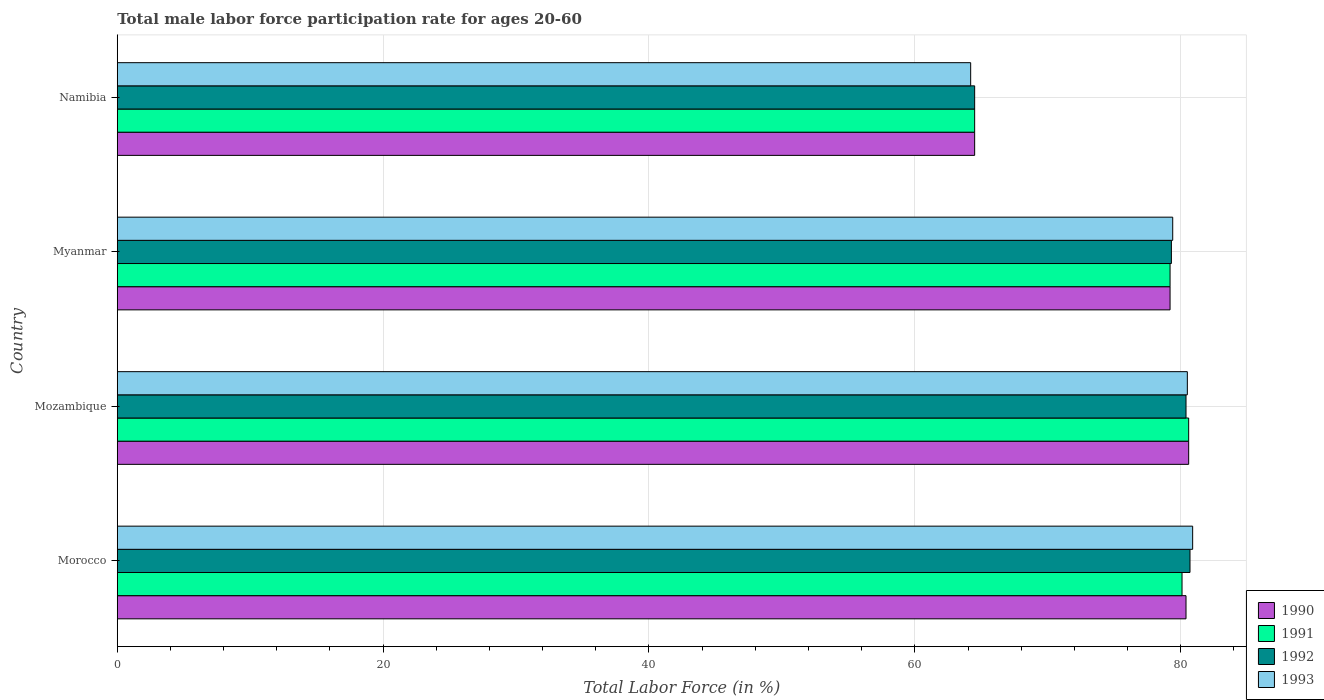Are the number of bars on each tick of the Y-axis equal?
Your answer should be very brief. Yes. How many bars are there on the 4th tick from the bottom?
Provide a short and direct response. 4. What is the label of the 4th group of bars from the top?
Offer a terse response. Morocco. What is the male labor force participation rate in 1992 in Mozambique?
Provide a short and direct response. 80.4. Across all countries, what is the maximum male labor force participation rate in 1990?
Give a very brief answer. 80.6. Across all countries, what is the minimum male labor force participation rate in 1993?
Your response must be concise. 64.2. In which country was the male labor force participation rate in 1993 maximum?
Offer a very short reply. Morocco. In which country was the male labor force participation rate in 1991 minimum?
Keep it short and to the point. Namibia. What is the total male labor force participation rate in 1990 in the graph?
Your answer should be very brief. 304.7. What is the difference between the male labor force participation rate in 1990 in Morocco and that in Mozambique?
Provide a succinct answer. -0.2. What is the difference between the male labor force participation rate in 1992 in Mozambique and the male labor force participation rate in 1991 in Myanmar?
Make the answer very short. 1.2. What is the average male labor force participation rate in 1990 per country?
Your answer should be compact. 76.17. What is the difference between the male labor force participation rate in 1990 and male labor force participation rate in 1991 in Morocco?
Provide a short and direct response. 0.3. What is the ratio of the male labor force participation rate in 1993 in Mozambique to that in Namibia?
Provide a succinct answer. 1.25. Is the male labor force participation rate in 1990 in Morocco less than that in Myanmar?
Ensure brevity in your answer.  No. What is the difference between the highest and the second highest male labor force participation rate in 1992?
Provide a succinct answer. 0.3. What is the difference between the highest and the lowest male labor force participation rate in 1992?
Provide a short and direct response. 16.2. Is it the case that in every country, the sum of the male labor force participation rate in 1990 and male labor force participation rate in 1992 is greater than the sum of male labor force participation rate in 1993 and male labor force participation rate in 1991?
Offer a terse response. No. What does the 3rd bar from the bottom in Mozambique represents?
Give a very brief answer. 1992. Is it the case that in every country, the sum of the male labor force participation rate in 1992 and male labor force participation rate in 1993 is greater than the male labor force participation rate in 1991?
Your answer should be compact. Yes. What is the difference between two consecutive major ticks on the X-axis?
Provide a short and direct response. 20. Does the graph contain grids?
Keep it short and to the point. Yes. Where does the legend appear in the graph?
Ensure brevity in your answer.  Bottom right. How many legend labels are there?
Offer a terse response. 4. What is the title of the graph?
Give a very brief answer. Total male labor force participation rate for ages 20-60. Does "1962" appear as one of the legend labels in the graph?
Give a very brief answer. No. What is the label or title of the Y-axis?
Your response must be concise. Country. What is the Total Labor Force (in %) of 1990 in Morocco?
Your answer should be compact. 80.4. What is the Total Labor Force (in %) of 1991 in Morocco?
Provide a succinct answer. 80.1. What is the Total Labor Force (in %) in 1992 in Morocco?
Offer a terse response. 80.7. What is the Total Labor Force (in %) in 1993 in Morocco?
Ensure brevity in your answer.  80.9. What is the Total Labor Force (in %) in 1990 in Mozambique?
Provide a short and direct response. 80.6. What is the Total Labor Force (in %) in 1991 in Mozambique?
Your answer should be very brief. 80.6. What is the Total Labor Force (in %) of 1992 in Mozambique?
Give a very brief answer. 80.4. What is the Total Labor Force (in %) in 1993 in Mozambique?
Ensure brevity in your answer.  80.5. What is the Total Labor Force (in %) in 1990 in Myanmar?
Offer a very short reply. 79.2. What is the Total Labor Force (in %) in 1991 in Myanmar?
Your response must be concise. 79.2. What is the Total Labor Force (in %) in 1992 in Myanmar?
Give a very brief answer. 79.3. What is the Total Labor Force (in %) in 1993 in Myanmar?
Give a very brief answer. 79.4. What is the Total Labor Force (in %) of 1990 in Namibia?
Offer a terse response. 64.5. What is the Total Labor Force (in %) in 1991 in Namibia?
Your response must be concise. 64.5. What is the Total Labor Force (in %) in 1992 in Namibia?
Your answer should be very brief. 64.5. What is the Total Labor Force (in %) of 1993 in Namibia?
Your response must be concise. 64.2. Across all countries, what is the maximum Total Labor Force (in %) of 1990?
Make the answer very short. 80.6. Across all countries, what is the maximum Total Labor Force (in %) in 1991?
Give a very brief answer. 80.6. Across all countries, what is the maximum Total Labor Force (in %) in 1992?
Keep it short and to the point. 80.7. Across all countries, what is the maximum Total Labor Force (in %) of 1993?
Ensure brevity in your answer.  80.9. Across all countries, what is the minimum Total Labor Force (in %) of 1990?
Provide a succinct answer. 64.5. Across all countries, what is the minimum Total Labor Force (in %) of 1991?
Make the answer very short. 64.5. Across all countries, what is the minimum Total Labor Force (in %) of 1992?
Offer a very short reply. 64.5. Across all countries, what is the minimum Total Labor Force (in %) in 1993?
Your answer should be compact. 64.2. What is the total Total Labor Force (in %) in 1990 in the graph?
Ensure brevity in your answer.  304.7. What is the total Total Labor Force (in %) in 1991 in the graph?
Ensure brevity in your answer.  304.4. What is the total Total Labor Force (in %) in 1992 in the graph?
Offer a terse response. 304.9. What is the total Total Labor Force (in %) of 1993 in the graph?
Offer a terse response. 305. What is the difference between the Total Labor Force (in %) in 1991 in Morocco and that in Mozambique?
Your answer should be very brief. -0.5. What is the difference between the Total Labor Force (in %) of 1992 in Morocco and that in Mozambique?
Keep it short and to the point. 0.3. What is the difference between the Total Labor Force (in %) in 1993 in Morocco and that in Mozambique?
Your answer should be very brief. 0.4. What is the difference between the Total Labor Force (in %) of 1990 in Morocco and that in Myanmar?
Offer a very short reply. 1.2. What is the difference between the Total Labor Force (in %) of 1993 in Morocco and that in Myanmar?
Your answer should be very brief. 1.5. What is the difference between the Total Labor Force (in %) of 1991 in Morocco and that in Namibia?
Your answer should be very brief. 15.6. What is the difference between the Total Labor Force (in %) in 1992 in Morocco and that in Namibia?
Offer a terse response. 16.2. What is the difference between the Total Labor Force (in %) of 1993 in Morocco and that in Namibia?
Offer a terse response. 16.7. What is the difference between the Total Labor Force (in %) in 1990 in Mozambique and that in Myanmar?
Your answer should be very brief. 1.4. What is the difference between the Total Labor Force (in %) in 1992 in Mozambique and that in Myanmar?
Keep it short and to the point. 1.1. What is the difference between the Total Labor Force (in %) in 1992 in Mozambique and that in Namibia?
Offer a very short reply. 15.9. What is the difference between the Total Labor Force (in %) of 1990 in Myanmar and that in Namibia?
Your answer should be very brief. 14.7. What is the difference between the Total Labor Force (in %) of 1991 in Myanmar and that in Namibia?
Give a very brief answer. 14.7. What is the difference between the Total Labor Force (in %) of 1990 in Morocco and the Total Labor Force (in %) of 1992 in Mozambique?
Keep it short and to the point. 0. What is the difference between the Total Labor Force (in %) in 1990 in Morocco and the Total Labor Force (in %) in 1993 in Mozambique?
Your answer should be compact. -0.1. What is the difference between the Total Labor Force (in %) of 1991 in Morocco and the Total Labor Force (in %) of 1993 in Mozambique?
Keep it short and to the point. -0.4. What is the difference between the Total Labor Force (in %) of 1991 in Morocco and the Total Labor Force (in %) of 1992 in Myanmar?
Make the answer very short. 0.8. What is the difference between the Total Labor Force (in %) of 1992 in Morocco and the Total Labor Force (in %) of 1993 in Myanmar?
Provide a succinct answer. 1.3. What is the difference between the Total Labor Force (in %) of 1990 in Morocco and the Total Labor Force (in %) of 1992 in Namibia?
Keep it short and to the point. 15.9. What is the difference between the Total Labor Force (in %) in 1990 in Morocco and the Total Labor Force (in %) in 1993 in Namibia?
Make the answer very short. 16.2. What is the difference between the Total Labor Force (in %) of 1990 in Mozambique and the Total Labor Force (in %) of 1992 in Myanmar?
Give a very brief answer. 1.3. What is the difference between the Total Labor Force (in %) in 1991 in Mozambique and the Total Labor Force (in %) in 1992 in Myanmar?
Your answer should be very brief. 1.3. What is the difference between the Total Labor Force (in %) of 1991 in Mozambique and the Total Labor Force (in %) of 1993 in Myanmar?
Provide a succinct answer. 1.2. What is the difference between the Total Labor Force (in %) of 1992 in Mozambique and the Total Labor Force (in %) of 1993 in Myanmar?
Give a very brief answer. 1. What is the difference between the Total Labor Force (in %) in 1990 in Mozambique and the Total Labor Force (in %) in 1991 in Namibia?
Ensure brevity in your answer.  16.1. What is the difference between the Total Labor Force (in %) of 1990 in Mozambique and the Total Labor Force (in %) of 1992 in Namibia?
Offer a very short reply. 16.1. What is the difference between the Total Labor Force (in %) of 1991 in Mozambique and the Total Labor Force (in %) of 1992 in Namibia?
Provide a succinct answer. 16.1. What is the difference between the Total Labor Force (in %) of 1991 in Mozambique and the Total Labor Force (in %) of 1993 in Namibia?
Your answer should be compact. 16.4. What is the difference between the Total Labor Force (in %) in 1990 in Myanmar and the Total Labor Force (in %) in 1991 in Namibia?
Provide a succinct answer. 14.7. What is the difference between the Total Labor Force (in %) in 1990 in Myanmar and the Total Labor Force (in %) in 1993 in Namibia?
Give a very brief answer. 15. What is the difference between the Total Labor Force (in %) in 1991 in Myanmar and the Total Labor Force (in %) in 1993 in Namibia?
Give a very brief answer. 15. What is the average Total Labor Force (in %) of 1990 per country?
Your answer should be compact. 76.17. What is the average Total Labor Force (in %) of 1991 per country?
Offer a terse response. 76.1. What is the average Total Labor Force (in %) of 1992 per country?
Your response must be concise. 76.22. What is the average Total Labor Force (in %) of 1993 per country?
Your response must be concise. 76.25. What is the difference between the Total Labor Force (in %) in 1990 and Total Labor Force (in %) in 1992 in Morocco?
Give a very brief answer. -0.3. What is the difference between the Total Labor Force (in %) in 1990 and Total Labor Force (in %) in 1992 in Mozambique?
Ensure brevity in your answer.  0.2. What is the difference between the Total Labor Force (in %) in 1991 and Total Labor Force (in %) in 1992 in Mozambique?
Offer a terse response. 0.2. What is the difference between the Total Labor Force (in %) in 1992 and Total Labor Force (in %) in 1993 in Mozambique?
Your answer should be compact. -0.1. What is the difference between the Total Labor Force (in %) in 1990 and Total Labor Force (in %) in 1992 in Myanmar?
Your response must be concise. -0.1. What is the difference between the Total Labor Force (in %) in 1990 and Total Labor Force (in %) in 1993 in Myanmar?
Ensure brevity in your answer.  -0.2. What is the difference between the Total Labor Force (in %) of 1992 and Total Labor Force (in %) of 1993 in Myanmar?
Ensure brevity in your answer.  -0.1. What is the difference between the Total Labor Force (in %) in 1990 and Total Labor Force (in %) in 1991 in Namibia?
Give a very brief answer. 0. What is the difference between the Total Labor Force (in %) in 1990 and Total Labor Force (in %) in 1992 in Namibia?
Offer a terse response. 0. What is the difference between the Total Labor Force (in %) of 1990 and Total Labor Force (in %) of 1993 in Namibia?
Your response must be concise. 0.3. What is the difference between the Total Labor Force (in %) in 1991 and Total Labor Force (in %) in 1993 in Namibia?
Make the answer very short. 0.3. What is the ratio of the Total Labor Force (in %) of 1990 in Morocco to that in Mozambique?
Offer a terse response. 1. What is the ratio of the Total Labor Force (in %) of 1992 in Morocco to that in Mozambique?
Make the answer very short. 1. What is the ratio of the Total Labor Force (in %) of 1990 in Morocco to that in Myanmar?
Offer a terse response. 1.02. What is the ratio of the Total Labor Force (in %) of 1991 in Morocco to that in Myanmar?
Your answer should be very brief. 1.01. What is the ratio of the Total Labor Force (in %) in 1992 in Morocco to that in Myanmar?
Keep it short and to the point. 1.02. What is the ratio of the Total Labor Force (in %) in 1993 in Morocco to that in Myanmar?
Make the answer very short. 1.02. What is the ratio of the Total Labor Force (in %) of 1990 in Morocco to that in Namibia?
Offer a very short reply. 1.25. What is the ratio of the Total Labor Force (in %) of 1991 in Morocco to that in Namibia?
Offer a terse response. 1.24. What is the ratio of the Total Labor Force (in %) in 1992 in Morocco to that in Namibia?
Give a very brief answer. 1.25. What is the ratio of the Total Labor Force (in %) in 1993 in Morocco to that in Namibia?
Provide a short and direct response. 1.26. What is the ratio of the Total Labor Force (in %) of 1990 in Mozambique to that in Myanmar?
Offer a very short reply. 1.02. What is the ratio of the Total Labor Force (in %) in 1991 in Mozambique to that in Myanmar?
Your answer should be compact. 1.02. What is the ratio of the Total Labor Force (in %) in 1992 in Mozambique to that in Myanmar?
Give a very brief answer. 1.01. What is the ratio of the Total Labor Force (in %) of 1993 in Mozambique to that in Myanmar?
Offer a terse response. 1.01. What is the ratio of the Total Labor Force (in %) of 1990 in Mozambique to that in Namibia?
Keep it short and to the point. 1.25. What is the ratio of the Total Labor Force (in %) in 1991 in Mozambique to that in Namibia?
Ensure brevity in your answer.  1.25. What is the ratio of the Total Labor Force (in %) in 1992 in Mozambique to that in Namibia?
Give a very brief answer. 1.25. What is the ratio of the Total Labor Force (in %) of 1993 in Mozambique to that in Namibia?
Make the answer very short. 1.25. What is the ratio of the Total Labor Force (in %) in 1990 in Myanmar to that in Namibia?
Your answer should be very brief. 1.23. What is the ratio of the Total Labor Force (in %) in 1991 in Myanmar to that in Namibia?
Keep it short and to the point. 1.23. What is the ratio of the Total Labor Force (in %) of 1992 in Myanmar to that in Namibia?
Provide a succinct answer. 1.23. What is the ratio of the Total Labor Force (in %) in 1993 in Myanmar to that in Namibia?
Your response must be concise. 1.24. What is the difference between the highest and the second highest Total Labor Force (in %) in 1990?
Offer a very short reply. 0.2. What is the difference between the highest and the second highest Total Labor Force (in %) of 1992?
Offer a terse response. 0.3. What is the difference between the highest and the second highest Total Labor Force (in %) in 1993?
Offer a terse response. 0.4. What is the difference between the highest and the lowest Total Labor Force (in %) of 1992?
Make the answer very short. 16.2. 